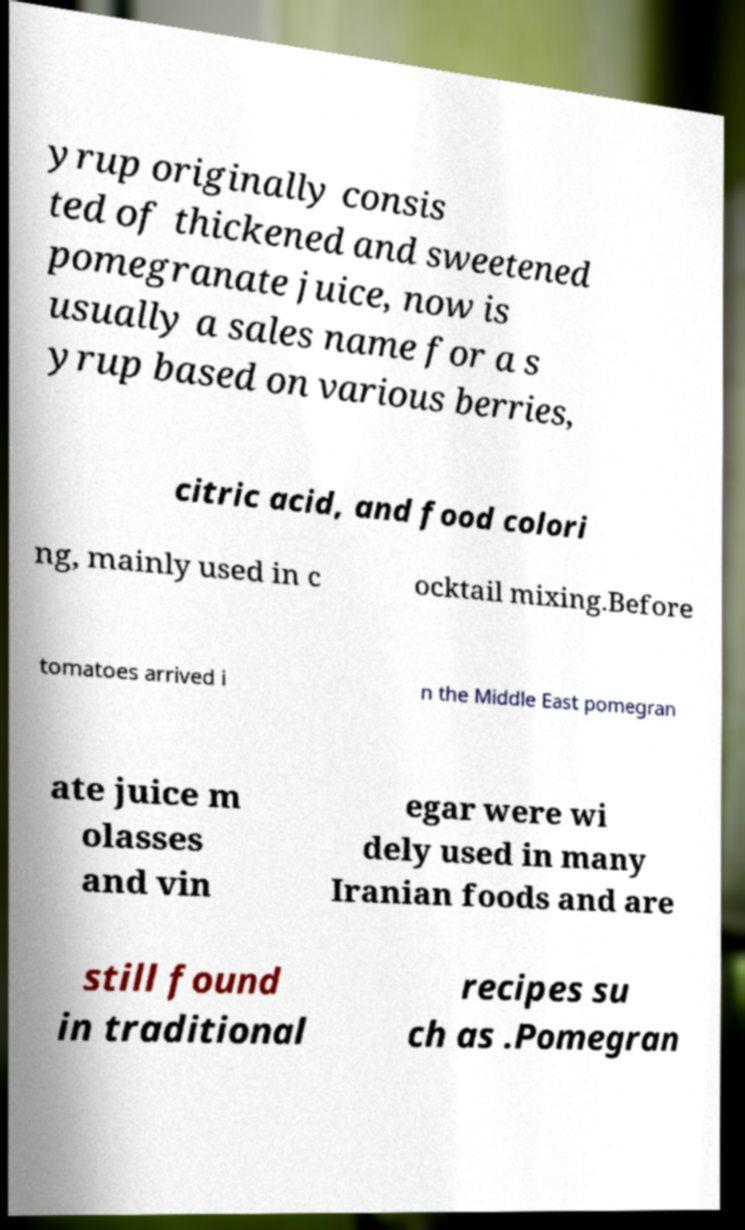Please read and relay the text visible in this image. What does it say? yrup originally consis ted of thickened and sweetened pomegranate juice, now is usually a sales name for a s yrup based on various berries, citric acid, and food colori ng, mainly used in c ocktail mixing.Before tomatoes arrived i n the Middle East pomegran ate juice m olasses and vin egar were wi dely used in many Iranian foods and are still found in traditional recipes su ch as .Pomegran 